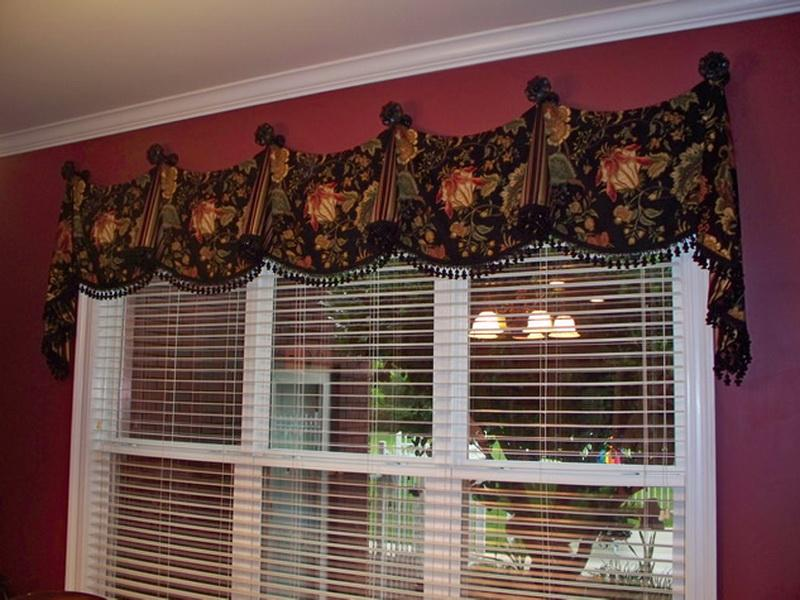What does the window treatment tell us about the possible use of this room? The window treatment, with its luxurious textile and elaborate design, suggests that this room may serve a formal purpose, such as a dining room or a sitting room meant for entertaining guests. The attention to detail in the decor indicates that the space is designed to make a statement and create an impression. It's likely that the room is arranged to facilitate conversation and social interaction, possibly adorned with other statement pieces like a chandelier, ornate furniture, and fine art - elements befitting a room that is created for hosting and sophistication. 